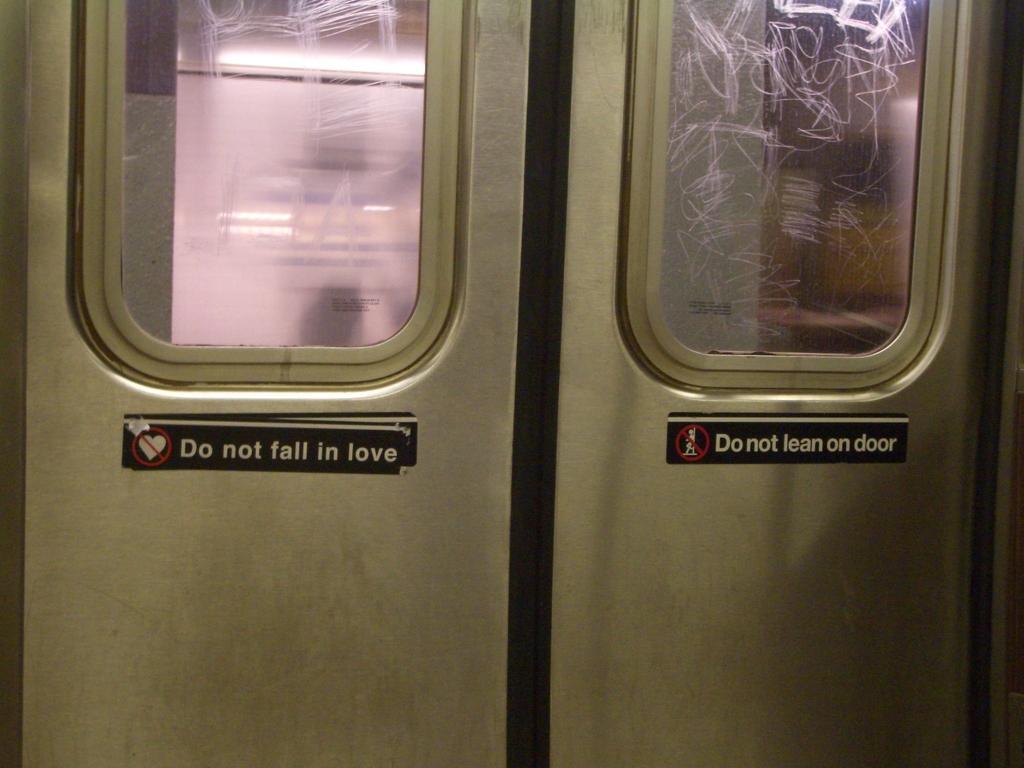In one or two sentences, can you explain what this image depicts? In this image there is a closed door with glass windows and some text on it. 